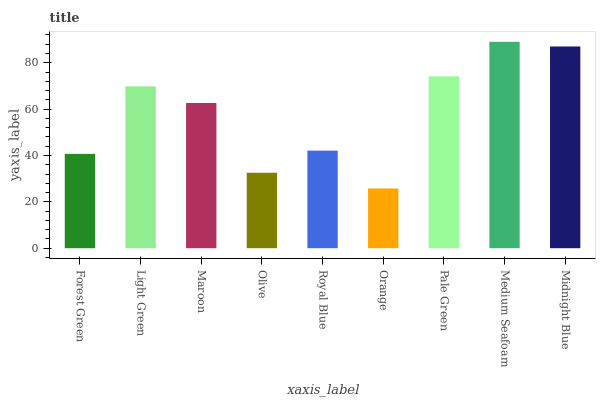Is Light Green the minimum?
Answer yes or no. No. Is Light Green the maximum?
Answer yes or no. No. Is Light Green greater than Forest Green?
Answer yes or no. Yes. Is Forest Green less than Light Green?
Answer yes or no. Yes. Is Forest Green greater than Light Green?
Answer yes or no. No. Is Light Green less than Forest Green?
Answer yes or no. No. Is Maroon the high median?
Answer yes or no. Yes. Is Maroon the low median?
Answer yes or no. Yes. Is Orange the high median?
Answer yes or no. No. Is Forest Green the low median?
Answer yes or no. No. 